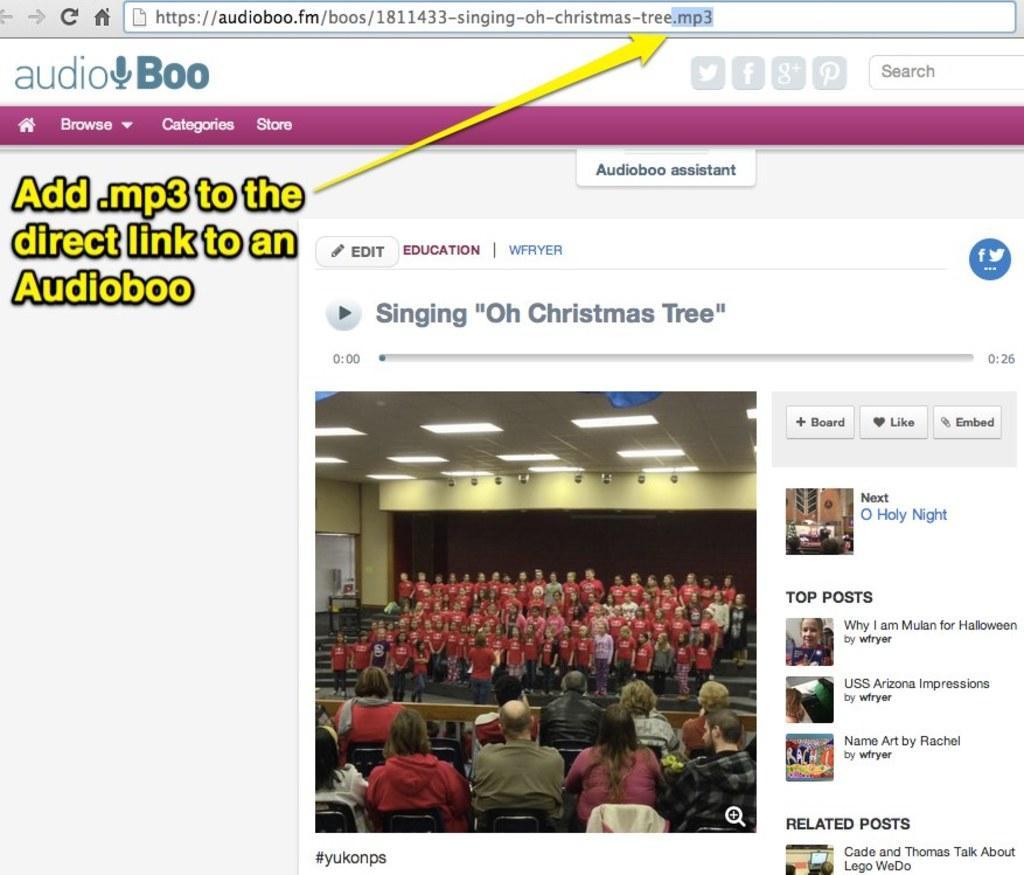Please provide a concise description of this image. In this image there is a screenshot of a browser web page. 